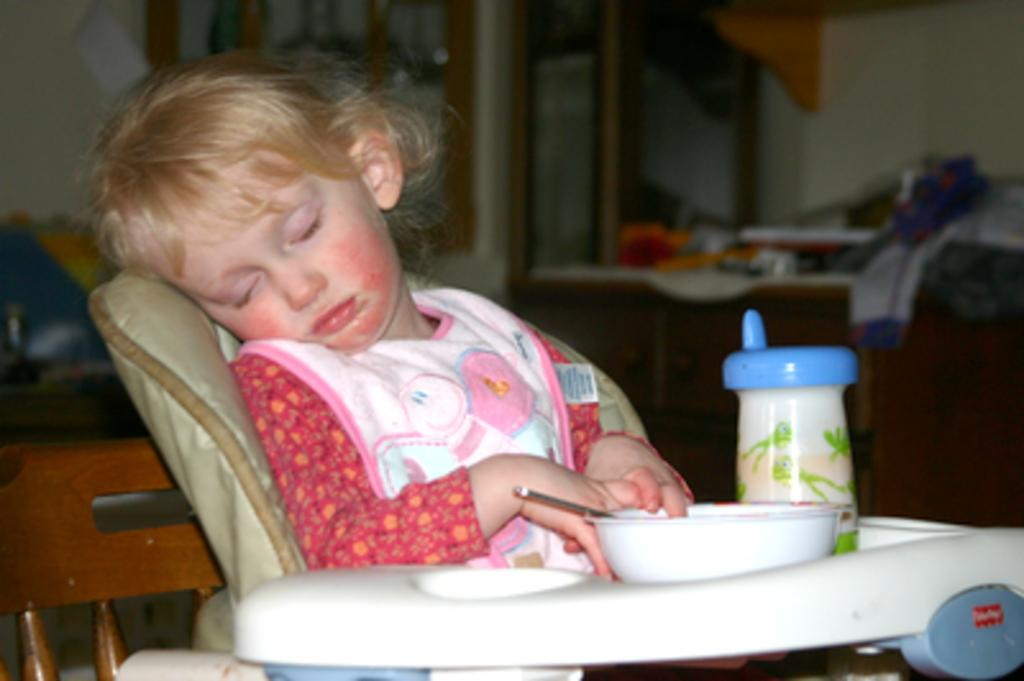What is the main subject of the image? There is a child in the image. What is the child doing in the image? The child is sleeping. What is the child wearing in the image? The child is wearing clothes. What objects can be seen in the image besides the child? There is a bowl and a wooden chair in the image. How would you describe the background of the image? The background of the image is blurred. What type of pot is being used to connect the child to the party in the image? There is no pot or party present in the image, and therefore no such connection can be observed. 